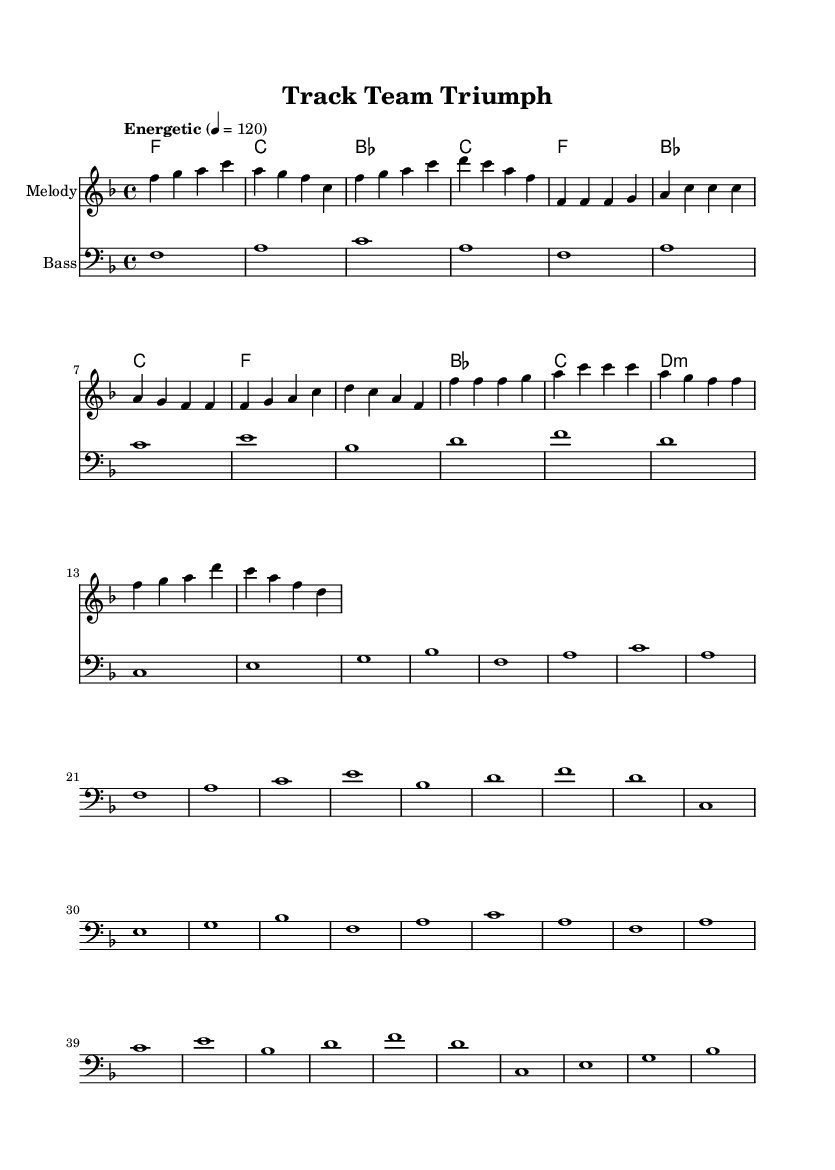What is the key signature of this music? The key signature is F major, which has one flat (B flat). This can be determined from the initial section of the sheet music where the key information is indicated.
Answer: F major What is the time signature of this music? The time signature is four-four, which is indicated at the beginning of the sheet music. It tells us that there are four beats in each measure and the quarter note gets one beat.
Answer: Four-four What is the tempo marking of this piece? The tempo marking is "Energetic" with a metronome marking of 120 beats per minute. This is specified at the beginning of the score, indicating the speed at which the piece should be played.
Answer: Energetic, 120 How many measures are in the chorus section? The chorus consists of four measures, as seen when examining the melody and harmonies in that section. Each measure includes specific notes that correspond to the lyrics and chords listed.
Answer: Four measures What is the main lyrical theme expressed in the song? The main lyrical theme is about teamwork and perseverance, as reflected in the lines like "together we rise, no mountain too high." This theme can be inferred from the lyrics included in the score.
Answer: Teamwork and perseverance What type of musical harmony is primarily used in the chorus? The chorus primarily uses major harmonies, which create a bright and uplifting sound typical of funk music. The chords include F major and G major, suggesting a positive and energetic vibe.
Answer: Major harmonies How does the bass line contribute to the funk style of this piece? The bass line features rhythmic and syncopated patterns that are characteristic of funk music, enhancing the groove and energy of the performance. This rhythmic emphasis is vital in creating the infectious feel typical of funk.
Answer: Rhythmic and syncopated patterns 